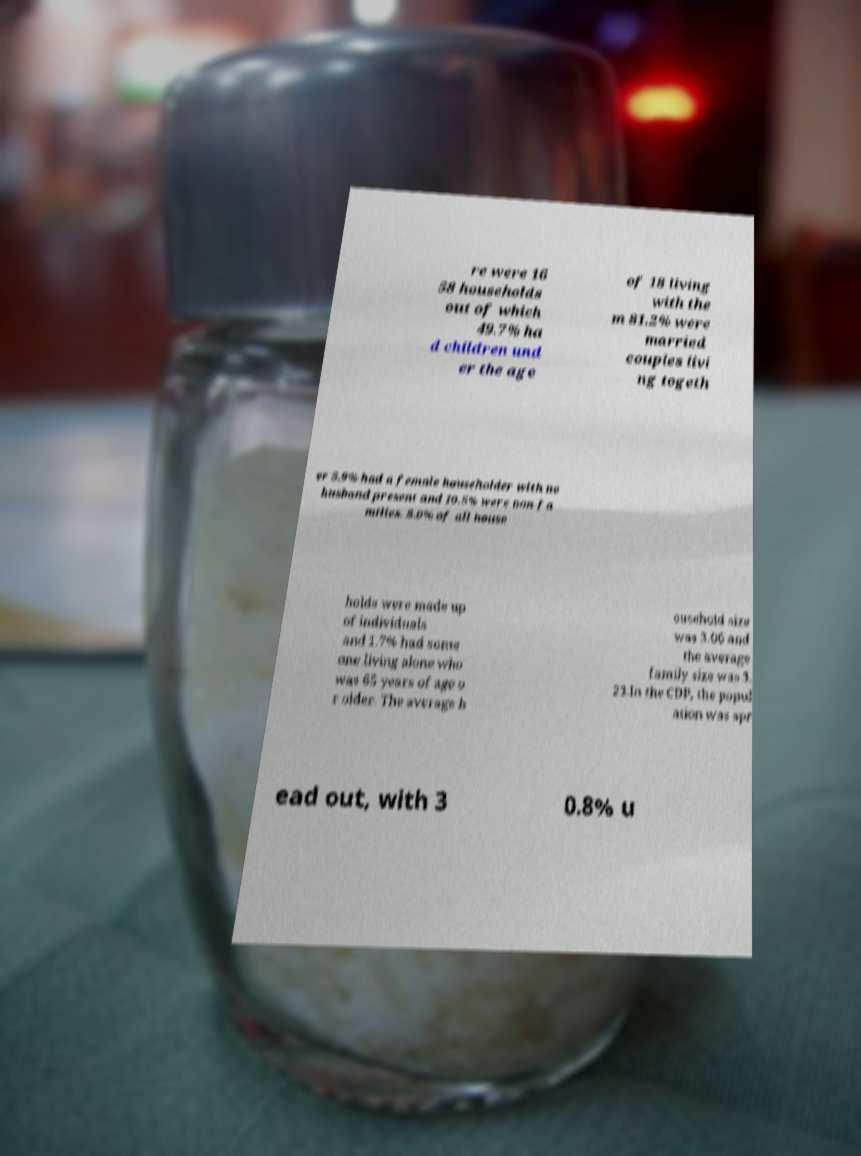Could you assist in decoding the text presented in this image and type it out clearly? re were 16 58 households out of which 49.7% ha d children und er the age of 18 living with the m 81.2% were married couples livi ng togeth er 5.9% had a female householder with no husband present and 10.5% were non-fa milies. 8.0% of all house holds were made up of individuals and 1.7% had some one living alone who was 65 years of age o r older. The average h ousehold size was 3.06 and the average family size was 3. 23.In the CDP, the popul ation was spr ead out, with 3 0.8% u 